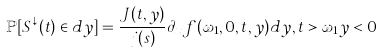<formula> <loc_0><loc_0><loc_500><loc_500>\mathbb { P } [ S ^ { \downarrow } ( t ) \in d y ] = \frac { J ( t , y ) } { j ( s ) } \partial _ { x } f ( \omega _ { 1 } , 0 , t , y ) d y , t > \omega _ { 1 } y < 0</formula> 